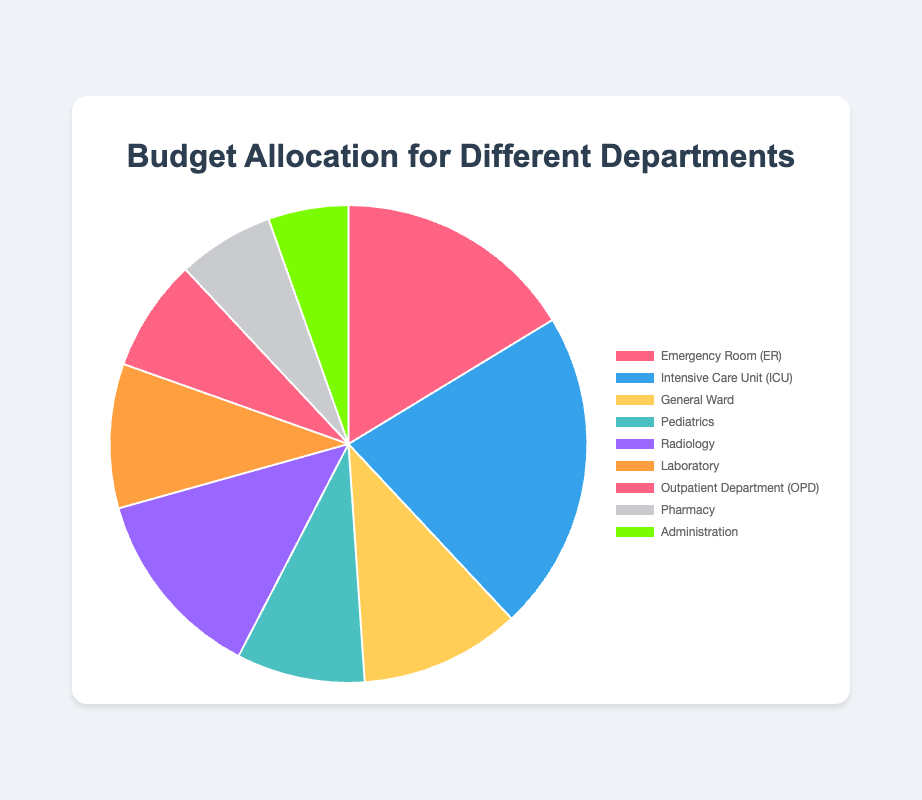Which department has the highest budget allocation? The department with the highest budget allocation is easily identifiable by looking at the largest segment of the pie chart. In this case, it's the Intensive Care Unit (ICU).
Answer: Intensive Care Unit (ICU) What is the total budget allocated to the General Ward and the Pediatrics departments? The total budget is calculated by summing the individual budgets of both departments. The General Ward has $100,000 and Pediatrics has $80,000. Summing these values gives $100,000 + $80,000 = $180,000.
Answer: $180,000 Which department has a higher budget allocation: Radiology or Laboratory? To determine which department has a higher budget, compare the values of the two departments directly. Radiology has $120,000 while Laboratory has $90,000. Therefore, Radiology has a higher budget.
Answer: Radiology By what percentage is the budget of the Intensive Care Unit (ICU) larger than the General Ward? To find this percentage, first find the difference between the ICU and General Ward budgets, which is $200,000 - $100,000 = $100,000. Then, calculate the percentage increase relative to the General Ward: ($100,000 / $100,000) * 100 = 100%.
Answer: 100% How much more is allocated to the Emergency Room (ER) compared to the Outpatient Department (OPD)? To find this, subtract the budget of the OPD from that of the ER: $150,000 - $70,000 = $80,000.
Answer: $80,000 What is the average budget allocation across all departments? To calculate the average, sum the budgets of all departments and divide by the number of departments. Sum is $150,000 + $200,000 + $100,000 + $80,000 + $120,000 + $90,000 + $70,000 + $60,000 + $50,000 = $920,000. There are 9 departments, so the average is $920,000 / 9 = $102,222.22.
Answer: $102,222.22 Which has the smallest budget allocation: Pharmacy or Administration? To find the smallest budget allocation between these two departments, compare their values. Pharmacy has $60,000 while Administration has $50,000. So, Administration has the smaller budget.
Answer: Administration If the total budget is increased by 10%, what will the new budget be for Radiology? First, find 10% of Radiology's budget: 10% of $120,000 is $12,000. Add this to the original budget to get the new budget: $120,000 + $12,000 = $132,000.
Answer: $132,000 What is the combined budget of the ER, ICU, and General Ward in percentage terms of the total budget? First, calculate the combined budget: $150,000 (ER) + $200,000 (ICU) + $100,000 (General Ward) = $450,000. The total budget is $920,000. The percentage is calculated as ($450,000 / $920,000) * 100 ≈ 48.91%.
Answer: 48.91% 